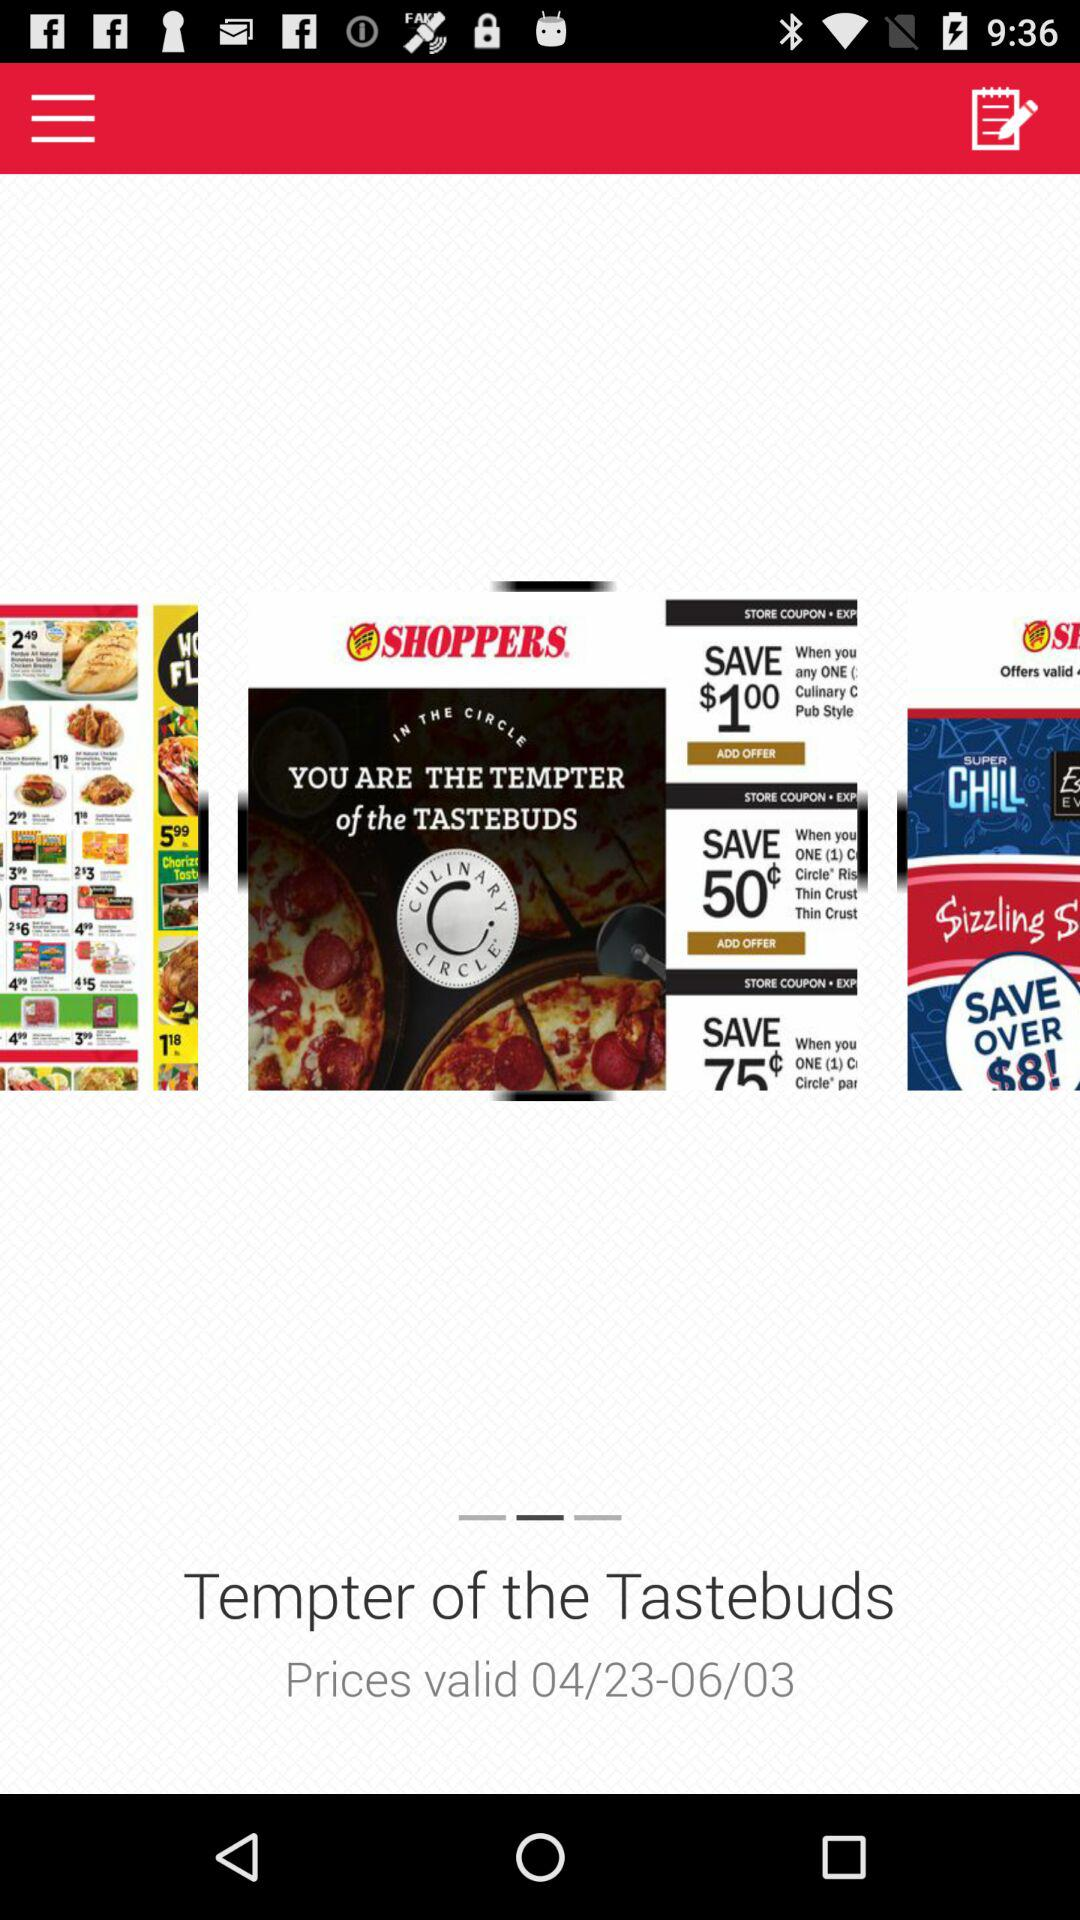Which items are on the user's grocery list?
When the provided information is insufficient, respond with <no answer>. <no answer> 